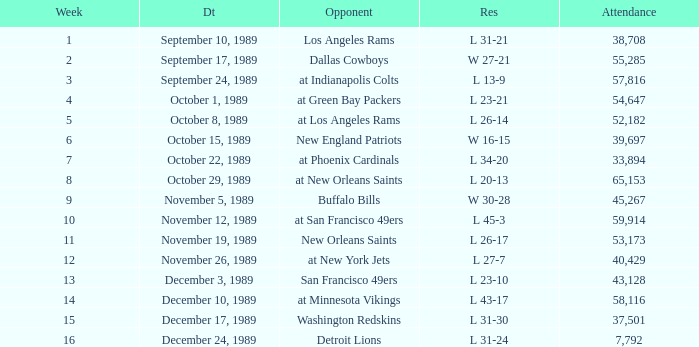On September 10, 1989 how many people attended the game? 38708.0. 